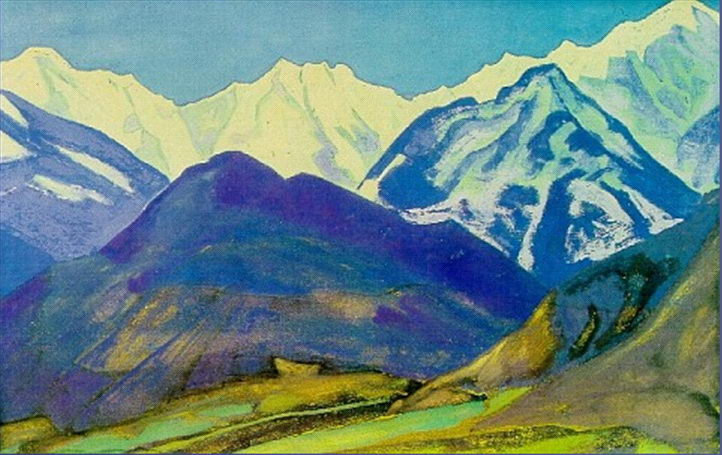How does the artist’s technique influence our perception of depth and distance in this landscape? The artist’s use of post-impressionist techniques, particularly the bold and somewhat abstract brushstrokes, creates a layered effect that enhances the perception of depth and distance. By varying the intensity and saturation of colors from the foreground to the background, and overlapping different shapes and shades, the artist crafts a sense of three-dimensionality. This method draws the viewer’s gaze from the detailed, vibrant foreground across the middle ranges and towards the snowy peaks in the distance, inviting an exploration of space that feels both expansive and immersive. 